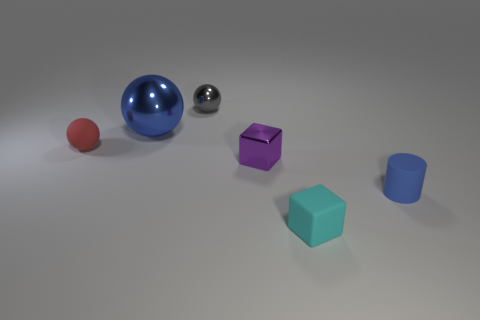Subtract all tiny shiny balls. How many balls are left? 2 Subtract all purple blocks. How many blocks are left? 1 Add 2 large blue metallic cylinders. How many objects exist? 8 Subtract all cubes. How many objects are left? 4 Subtract 1 cylinders. How many cylinders are left? 0 Subtract 0 blue cubes. How many objects are left? 6 Subtract all purple cylinders. Subtract all green cubes. How many cylinders are left? 1 Subtract all brown balls. How many purple blocks are left? 1 Subtract all red balls. Subtract all large red metal things. How many objects are left? 5 Add 2 big blue metallic spheres. How many big blue metallic spheres are left? 3 